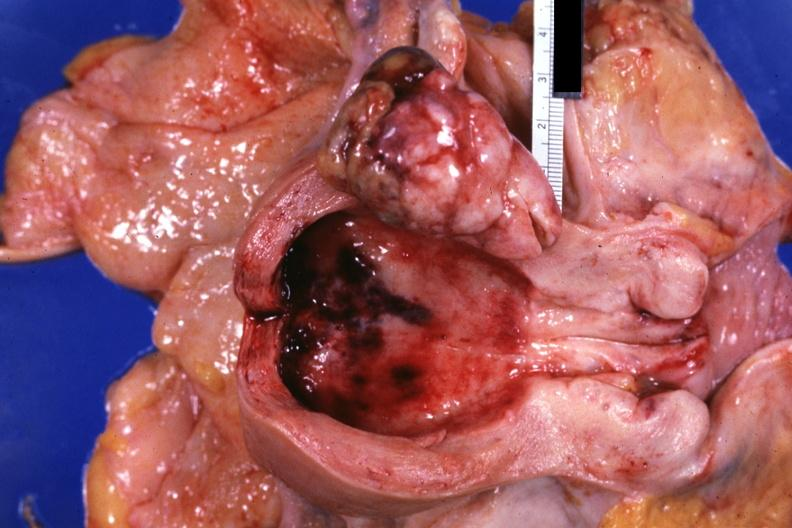what is present?
Answer the question using a single word or phrase. Female reproductive 